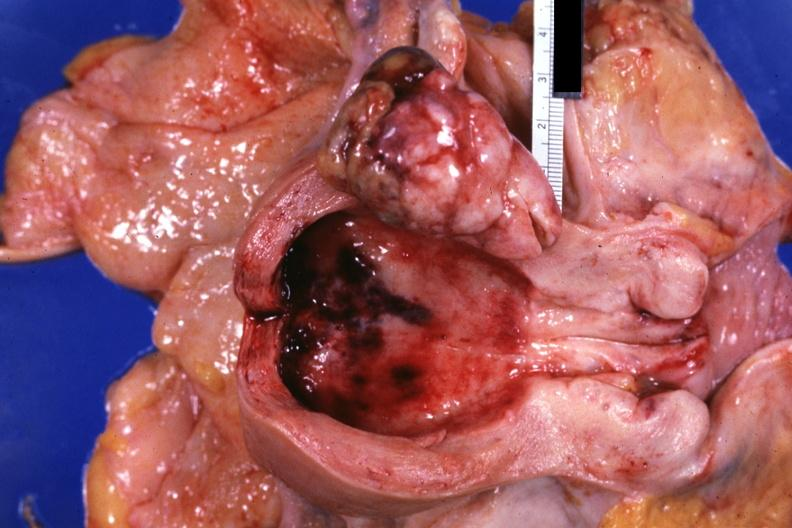what is present?
Answer the question using a single word or phrase. Female reproductive 